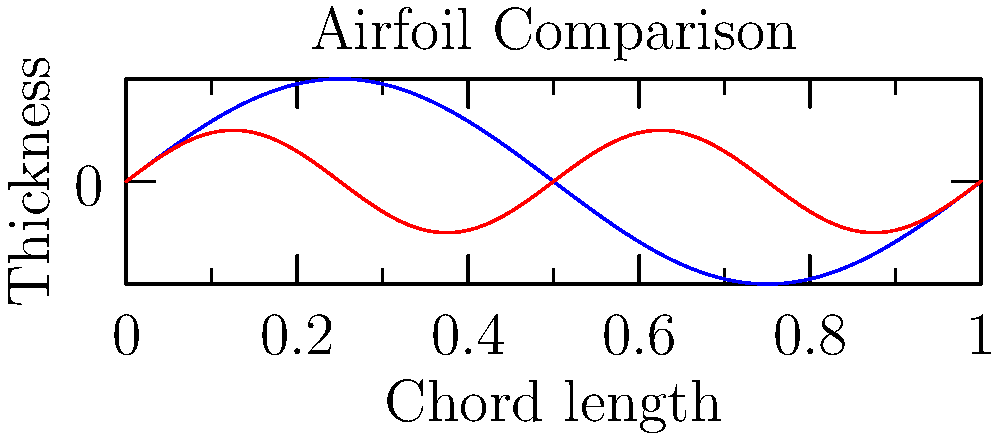Based on the graph comparing a bird-inspired airfoil design to a conventional airfoil, which characteristic of the bird-inspired design is likely to contribute most to its improved aerodynamic efficiency at low Reynolds numbers? To answer this question, let's analyze the graph step-by-step:

1. The graph shows two airfoil profiles: a bird-inspired design (blue) and a conventional design (red).

2. The x-axis represents the chord length, while the y-axis represents the thickness of the airfoil.

3. Observe that the bird-inspired airfoil has:
   a) A greater maximum thickness
   b) A more pronounced camber (curvature)
   c) A smoother, more gradual thickness distribution

4. At low Reynolds numbers, which are typical for small-scale flight or low-speed conditions, the following factors contribute to aerodynamic efficiency:
   a) Reduced flow separation
   b) Enhanced lift generation
   c) Decreased drag

5. The most significant feature of the bird-inspired airfoil that addresses these factors is its pronounced camber.

6. A more cambered airfoil:
   a) Generates higher lift coefficients at low angles of attack
   b) Delays flow separation by creating a more favorable pressure gradient
   c) Improves the lift-to-drag ratio, especially at low Reynolds numbers

7. While the greater maximum thickness and smoother thickness distribution also contribute to efficiency, the camber is the most influential factor for low Reynolds number performance.

Therefore, the pronounced camber of the bird-inspired airfoil design is likely to contribute most to its improved aerodynamic efficiency at low Reynolds numbers.
Answer: Pronounced camber 